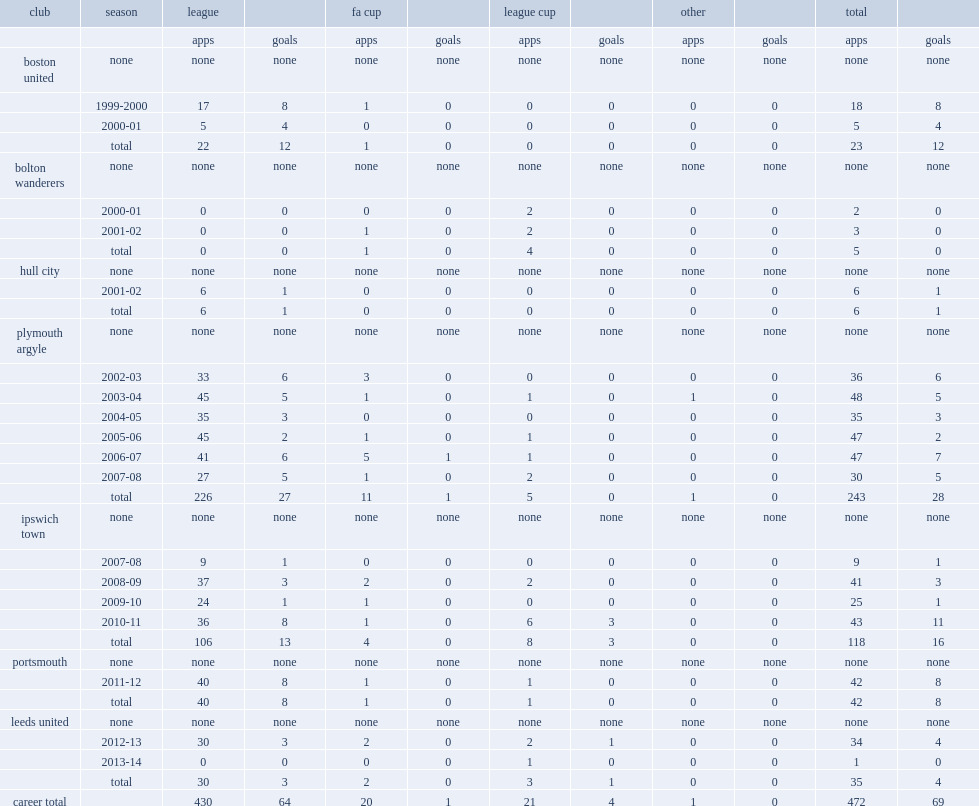How many goals did david norris score for plymouth argyle totally? 28.0. 